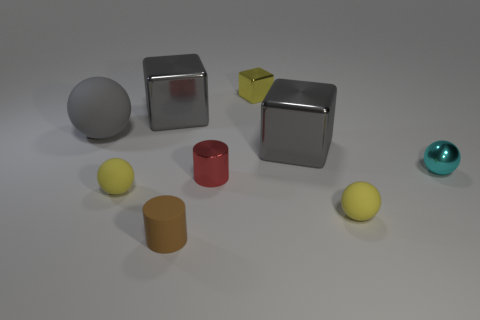Is there anything else of the same color as the large rubber ball?
Your response must be concise. Yes. Do the small metallic block and the small rubber sphere that is on the left side of the small yellow cube have the same color?
Offer a terse response. Yes. How big is the yellow matte ball on the right side of the tiny matte thing that is to the left of the gray block that is behind the big gray rubber ball?
Your response must be concise. Small. There is a shiny object behind the big gray shiny block behind the gray matte thing; what is its size?
Provide a short and direct response. Small. How many tiny objects are yellow metallic things or metal spheres?
Provide a succinct answer. 2. Is the number of tiny yellow matte objects less than the number of gray things?
Your response must be concise. Yes. Are there more tiny green cylinders than red things?
Your answer should be compact. No. How many other objects are there of the same color as the large rubber thing?
Your response must be concise. 2. How many tiny yellow shiny blocks are behind the tiny object that is behind the small shiny sphere?
Keep it short and to the point. 0. There is a tiny red metal thing; are there any cylinders in front of it?
Offer a terse response. Yes. 